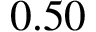<formula> <loc_0><loc_0><loc_500><loc_500>0 . 5 0</formula> 